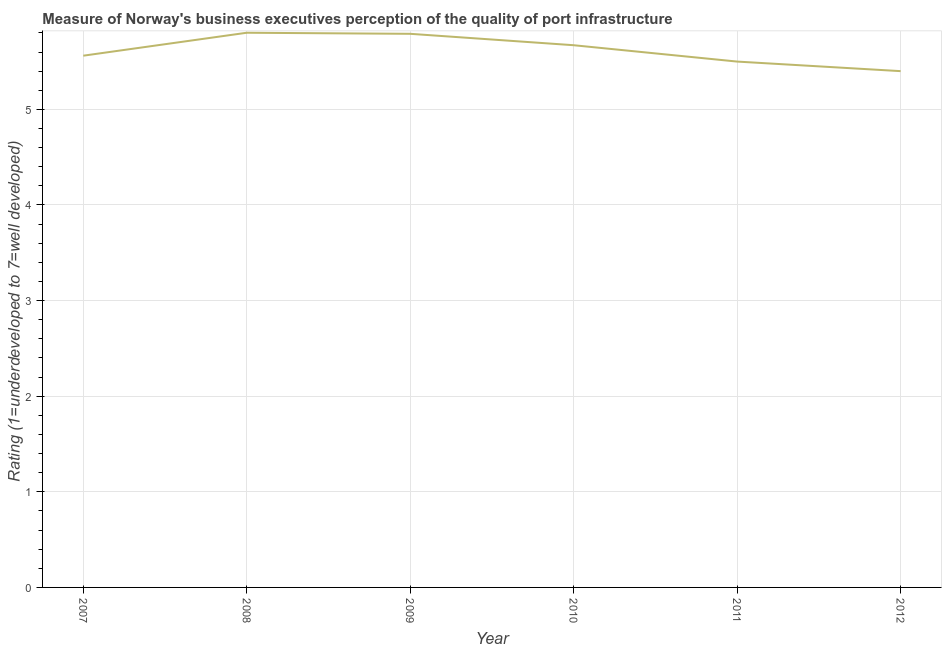What is the rating measuring quality of port infrastructure in 2010?
Your answer should be very brief. 5.67. Across all years, what is the maximum rating measuring quality of port infrastructure?
Provide a short and direct response. 5.8. In which year was the rating measuring quality of port infrastructure minimum?
Provide a succinct answer. 2012. What is the sum of the rating measuring quality of port infrastructure?
Your answer should be compact. 33.72. What is the difference between the rating measuring quality of port infrastructure in 2007 and 2009?
Offer a very short reply. -0.23. What is the average rating measuring quality of port infrastructure per year?
Give a very brief answer. 5.62. What is the median rating measuring quality of port infrastructure?
Ensure brevity in your answer.  5.62. Do a majority of the years between 2009 and 2011 (inclusive) have rating measuring quality of port infrastructure greater than 4.8 ?
Make the answer very short. Yes. What is the ratio of the rating measuring quality of port infrastructure in 2009 to that in 2012?
Give a very brief answer. 1.07. What is the difference between the highest and the second highest rating measuring quality of port infrastructure?
Keep it short and to the point. 0.01. What is the difference between the highest and the lowest rating measuring quality of port infrastructure?
Offer a very short reply. 0.4. In how many years, is the rating measuring quality of port infrastructure greater than the average rating measuring quality of port infrastructure taken over all years?
Give a very brief answer. 3. How many lines are there?
Your answer should be compact. 1. What is the title of the graph?
Provide a succinct answer. Measure of Norway's business executives perception of the quality of port infrastructure. What is the label or title of the Y-axis?
Ensure brevity in your answer.  Rating (1=underdeveloped to 7=well developed) . What is the Rating (1=underdeveloped to 7=well developed)  in 2007?
Provide a succinct answer. 5.56. What is the Rating (1=underdeveloped to 7=well developed)  in 2008?
Give a very brief answer. 5.8. What is the Rating (1=underdeveloped to 7=well developed)  of 2009?
Give a very brief answer. 5.79. What is the Rating (1=underdeveloped to 7=well developed)  of 2010?
Provide a succinct answer. 5.67. What is the Rating (1=underdeveloped to 7=well developed)  of 2012?
Provide a succinct answer. 5.4. What is the difference between the Rating (1=underdeveloped to 7=well developed)  in 2007 and 2008?
Keep it short and to the point. -0.24. What is the difference between the Rating (1=underdeveloped to 7=well developed)  in 2007 and 2009?
Provide a short and direct response. -0.23. What is the difference between the Rating (1=underdeveloped to 7=well developed)  in 2007 and 2010?
Provide a succinct answer. -0.11. What is the difference between the Rating (1=underdeveloped to 7=well developed)  in 2007 and 2011?
Keep it short and to the point. 0.06. What is the difference between the Rating (1=underdeveloped to 7=well developed)  in 2007 and 2012?
Offer a terse response. 0.16. What is the difference between the Rating (1=underdeveloped to 7=well developed)  in 2008 and 2009?
Make the answer very short. 0.01. What is the difference between the Rating (1=underdeveloped to 7=well developed)  in 2008 and 2010?
Ensure brevity in your answer.  0.13. What is the difference between the Rating (1=underdeveloped to 7=well developed)  in 2008 and 2011?
Ensure brevity in your answer.  0.3. What is the difference between the Rating (1=underdeveloped to 7=well developed)  in 2008 and 2012?
Give a very brief answer. 0.4. What is the difference between the Rating (1=underdeveloped to 7=well developed)  in 2009 and 2010?
Offer a terse response. 0.12. What is the difference between the Rating (1=underdeveloped to 7=well developed)  in 2009 and 2011?
Provide a succinct answer. 0.29. What is the difference between the Rating (1=underdeveloped to 7=well developed)  in 2009 and 2012?
Your answer should be compact. 0.39. What is the difference between the Rating (1=underdeveloped to 7=well developed)  in 2010 and 2011?
Your answer should be very brief. 0.17. What is the difference between the Rating (1=underdeveloped to 7=well developed)  in 2010 and 2012?
Give a very brief answer. 0.27. What is the ratio of the Rating (1=underdeveloped to 7=well developed)  in 2007 to that in 2009?
Provide a short and direct response. 0.96. What is the ratio of the Rating (1=underdeveloped to 7=well developed)  in 2007 to that in 2010?
Keep it short and to the point. 0.98. What is the ratio of the Rating (1=underdeveloped to 7=well developed)  in 2007 to that in 2011?
Ensure brevity in your answer.  1.01. What is the ratio of the Rating (1=underdeveloped to 7=well developed)  in 2007 to that in 2012?
Ensure brevity in your answer.  1.03. What is the ratio of the Rating (1=underdeveloped to 7=well developed)  in 2008 to that in 2009?
Your response must be concise. 1. What is the ratio of the Rating (1=underdeveloped to 7=well developed)  in 2008 to that in 2010?
Give a very brief answer. 1.02. What is the ratio of the Rating (1=underdeveloped to 7=well developed)  in 2008 to that in 2011?
Ensure brevity in your answer.  1.05. What is the ratio of the Rating (1=underdeveloped to 7=well developed)  in 2008 to that in 2012?
Make the answer very short. 1.07. What is the ratio of the Rating (1=underdeveloped to 7=well developed)  in 2009 to that in 2011?
Provide a succinct answer. 1.05. What is the ratio of the Rating (1=underdeveloped to 7=well developed)  in 2009 to that in 2012?
Provide a succinct answer. 1.07. What is the ratio of the Rating (1=underdeveloped to 7=well developed)  in 2010 to that in 2011?
Your answer should be very brief. 1.03. 